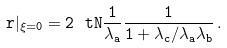<formula> <loc_0><loc_0><loc_500><loc_500>\tt r | _ { \xi = 0 } = 2 \ t N \frac { 1 } { \lambda _ { a } } \frac { 1 } { 1 + \lambda _ { c } / \lambda _ { a } \lambda _ { b } } \, .</formula> 